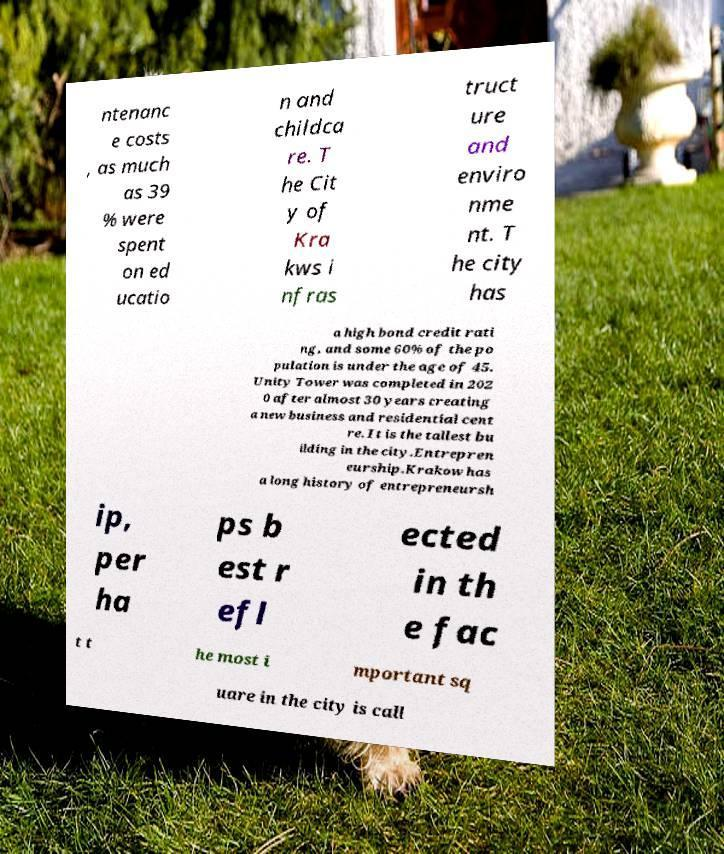Can you accurately transcribe the text from the provided image for me? ntenanc e costs , as much as 39 % were spent on ed ucatio n and childca re. T he Cit y of Kra kws i nfras truct ure and enviro nme nt. T he city has a high bond credit rati ng, and some 60% of the po pulation is under the age of 45. Unity Tower was completed in 202 0 after almost 30 years creating a new business and residential cent re. It is the tallest bu ilding in the city.Entrepren eurship.Krakow has a long history of entrepreneursh ip, per ha ps b est r efl ected in th e fac t t he most i mportant sq uare in the city is call 